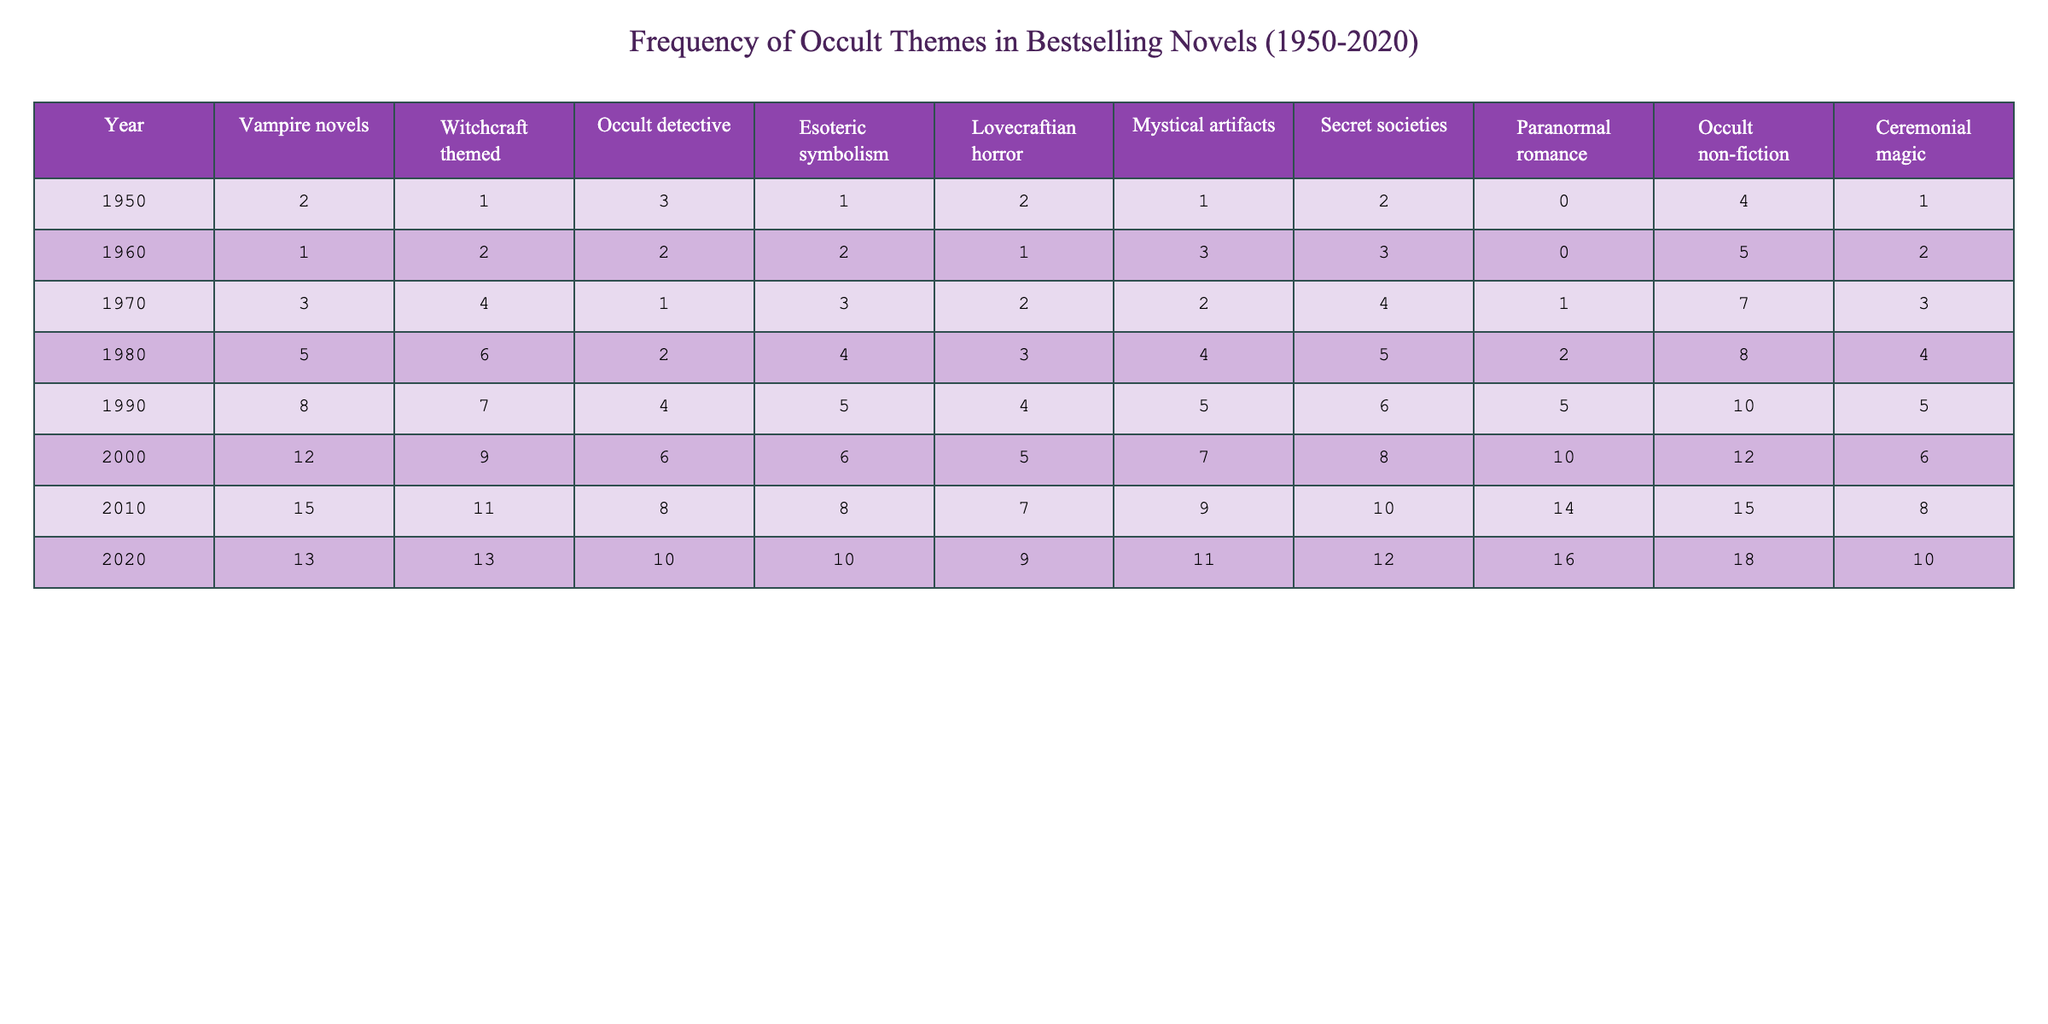What was the highest number of vampire novels published in a single decade? Looking at the table, the highest value for vampire novels in any given year is 15 in 2010. To find the highest number within a decade, we can observe the year ranges: for the 2000s, it was 12 in 2000 to 2009. For 2010, it is 15, therefore 2010 is the highest year for vampire novels.
Answer: 15 In which year were the fewest witchcraft-themed novels published? In the table, we see the values for witchcraft-themed novels across all years. The minimum value appears in 1950 with only 1 witchcraft-themed novel.
Answer: 1 Which occult theme has the highest total publication count from 1950 to 2020? To answer this, sum the values for each theme across all years: Vampire novels (62), Witchcraft themed (63), Occult detective (42), Esoteric symbolism (46), Lovecraftian horror (40), Mystical artifacts (47), Secret societies (55), Paranormal romance (38), Occult non-fiction (78), Ceremonial magic (46). The highest sum is for occult non-fiction with a total of 78.
Answer: Occult non-fiction True or False: The number of paranormal romance novels published increased every decade from 1950 to 2020. Checking the values for paranormal romance indicates that they were 0 in 1950, 3 in 1960, 4 in 1970, 5 in 1980, 6 in 1990, 8 in 2000, 10 in 2010, and 12 in 2020. Thus, it shows a consistent increase, making the statement true.
Answer: True What is the average number of ceremonial magic publications from 1950 to 2020? Add the values for ceremonial magic (1 + 2 + 3 + 4 + 5 + 6 + 8 + 10 = 39) and divide by the total years (8). So, 39/8 = 4.875, rounded to the nearest whole number gives an average of approximately 5.
Answer: 5 Which year had the largest increase in mystical artifacts publications compared to the previous year? Observing the mystical artifacts column: 1 (1950), 3 (1960), 4 (1970), 4 (1980), 5 (1990), 7 (2000), 9 (2010), and 11 (2020). The largest increase is from 9 in 2010 to 11 in 2020, which is an increase of 2 compared to the previous year.
Answer: 2 In the 2000s, did the number of occult detective novels surpass that of Lovecraftian horror novels? Checking the numbers for the 2000s (2000 to 2009), occult detective novels had a high of 6, and Lovecraftian horror had 5. Yes, occult detective novels did surpass Lovecraftian horror novels in that decade.
Answer: Yes 